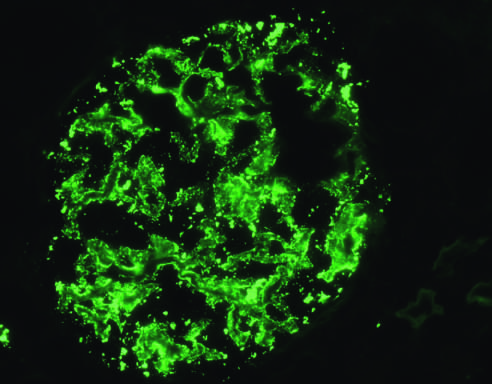s the immediate vascular and smooth muscle reaction to allergen detected by immunofluorescence?
Answer the question using a single word or phrase. No 